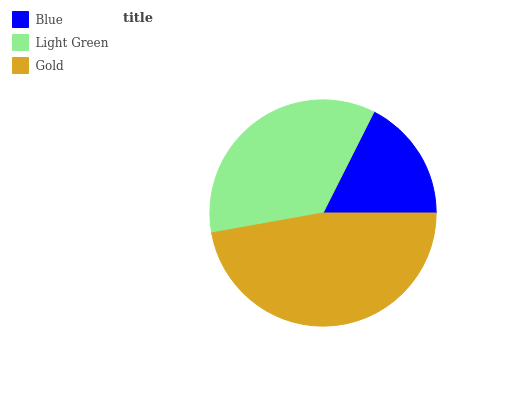Is Blue the minimum?
Answer yes or no. Yes. Is Gold the maximum?
Answer yes or no. Yes. Is Light Green the minimum?
Answer yes or no. No. Is Light Green the maximum?
Answer yes or no. No. Is Light Green greater than Blue?
Answer yes or no. Yes. Is Blue less than Light Green?
Answer yes or no. Yes. Is Blue greater than Light Green?
Answer yes or no. No. Is Light Green less than Blue?
Answer yes or no. No. Is Light Green the high median?
Answer yes or no. Yes. Is Light Green the low median?
Answer yes or no. Yes. Is Blue the high median?
Answer yes or no. No. Is Blue the low median?
Answer yes or no. No. 